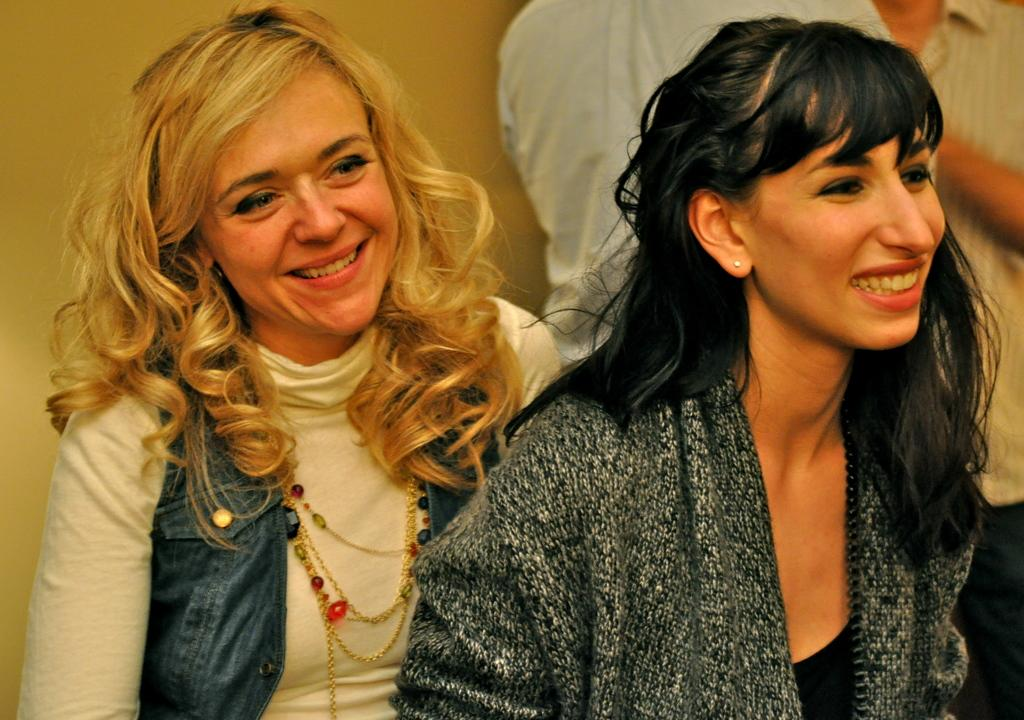How many people are in the image? There are two people in the image. Can you describe the expressions on their faces? The women in the image are smiling. What is the gender of the people in the image? The people in the image are women. What can be seen in the background of the image? There is a wall visible in the background of the image. What type of land can be seen in the image? There is no land visible in the image; it features two women standing in front of a wall. How many jars are present on the team in the image? There are no jars or teams present in the image; it features two women smiling. 